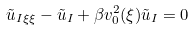Convert formula to latex. <formula><loc_0><loc_0><loc_500><loc_500>\tilde { u } _ { I \xi \xi } - \tilde { u } _ { I } + \beta v _ { 0 } ^ { 2 } ( \xi ) \tilde { u } _ { I } = 0</formula> 